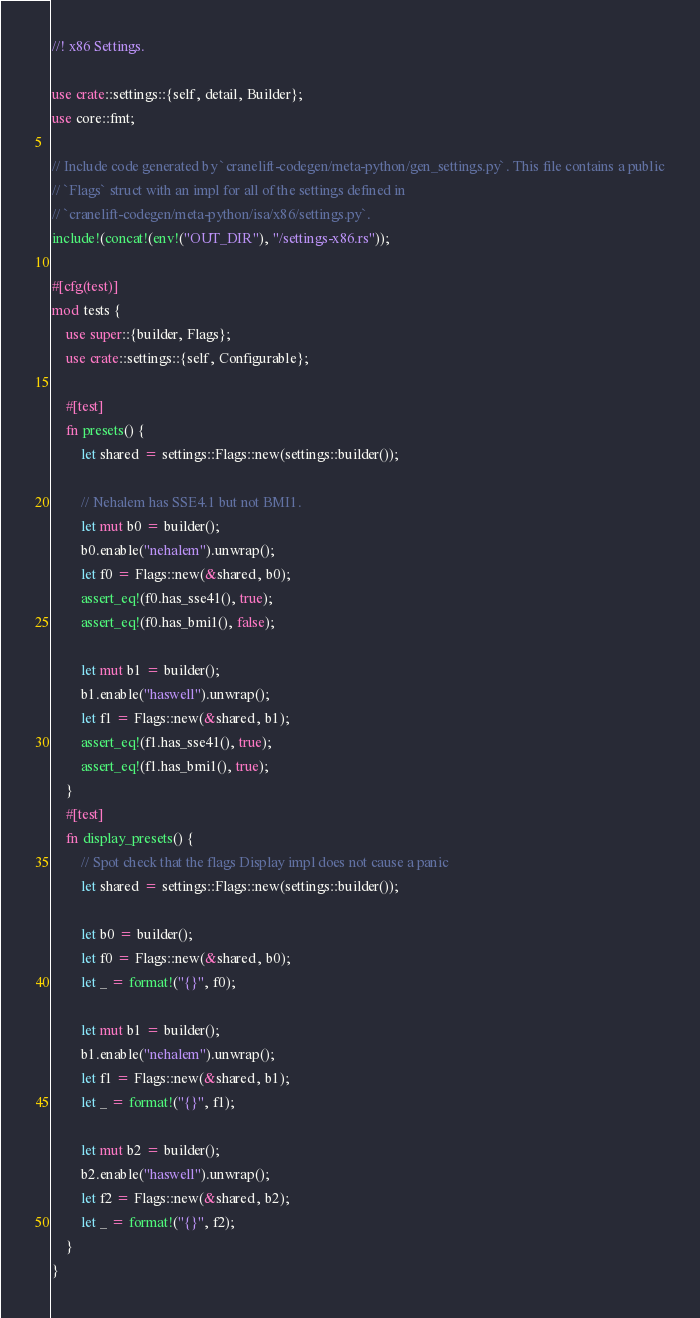<code> <loc_0><loc_0><loc_500><loc_500><_Rust_>//! x86 Settings.

use crate::settings::{self, detail, Builder};
use core::fmt;

// Include code generated by `cranelift-codegen/meta-python/gen_settings.py`. This file contains a public
// `Flags` struct with an impl for all of the settings defined in
// `cranelift-codegen/meta-python/isa/x86/settings.py`.
include!(concat!(env!("OUT_DIR"), "/settings-x86.rs"));

#[cfg(test)]
mod tests {
    use super::{builder, Flags};
    use crate::settings::{self, Configurable};

    #[test]
    fn presets() {
        let shared = settings::Flags::new(settings::builder());

        // Nehalem has SSE4.1 but not BMI1.
        let mut b0 = builder();
        b0.enable("nehalem").unwrap();
        let f0 = Flags::new(&shared, b0);
        assert_eq!(f0.has_sse41(), true);
        assert_eq!(f0.has_bmi1(), false);

        let mut b1 = builder();
        b1.enable("haswell").unwrap();
        let f1 = Flags::new(&shared, b1);
        assert_eq!(f1.has_sse41(), true);
        assert_eq!(f1.has_bmi1(), true);
    }
    #[test]
    fn display_presets() {
        // Spot check that the flags Display impl does not cause a panic
        let shared = settings::Flags::new(settings::builder());

        let b0 = builder();
        let f0 = Flags::new(&shared, b0);
        let _ = format!("{}", f0);

        let mut b1 = builder();
        b1.enable("nehalem").unwrap();
        let f1 = Flags::new(&shared, b1);
        let _ = format!("{}", f1);

        let mut b2 = builder();
        b2.enable("haswell").unwrap();
        let f2 = Flags::new(&shared, b2);
        let _ = format!("{}", f2);
    }
}
</code> 